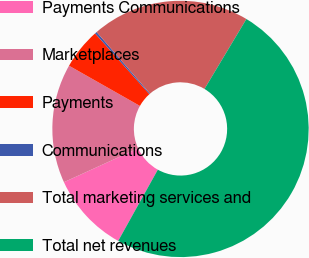<chart> <loc_0><loc_0><loc_500><loc_500><pie_chart><fcel>Payments Communications<fcel>Marketplaces<fcel>Payments<fcel>Communications<fcel>Total marketing services and<fcel>Total net revenues<nl><fcel>10.1%<fcel>15.03%<fcel>5.18%<fcel>0.26%<fcel>19.95%<fcel>49.49%<nl></chart> 